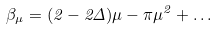Convert formula to latex. <formula><loc_0><loc_0><loc_500><loc_500>\beta _ { \mu } = ( 2 - 2 \Delta ) \mu - \pi \mu ^ { 2 } + \dots</formula> 